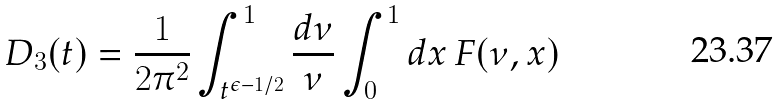Convert formula to latex. <formula><loc_0><loc_0><loc_500><loc_500>D _ { 3 } ( t ) = \frac { 1 } { 2 \pi ^ { 2 } } \int _ { t ^ { \epsilon - 1 / 2 } } ^ { 1 } \frac { d \nu } { \nu } \int _ { 0 } ^ { 1 } d x \, F ( \nu , x )</formula> 